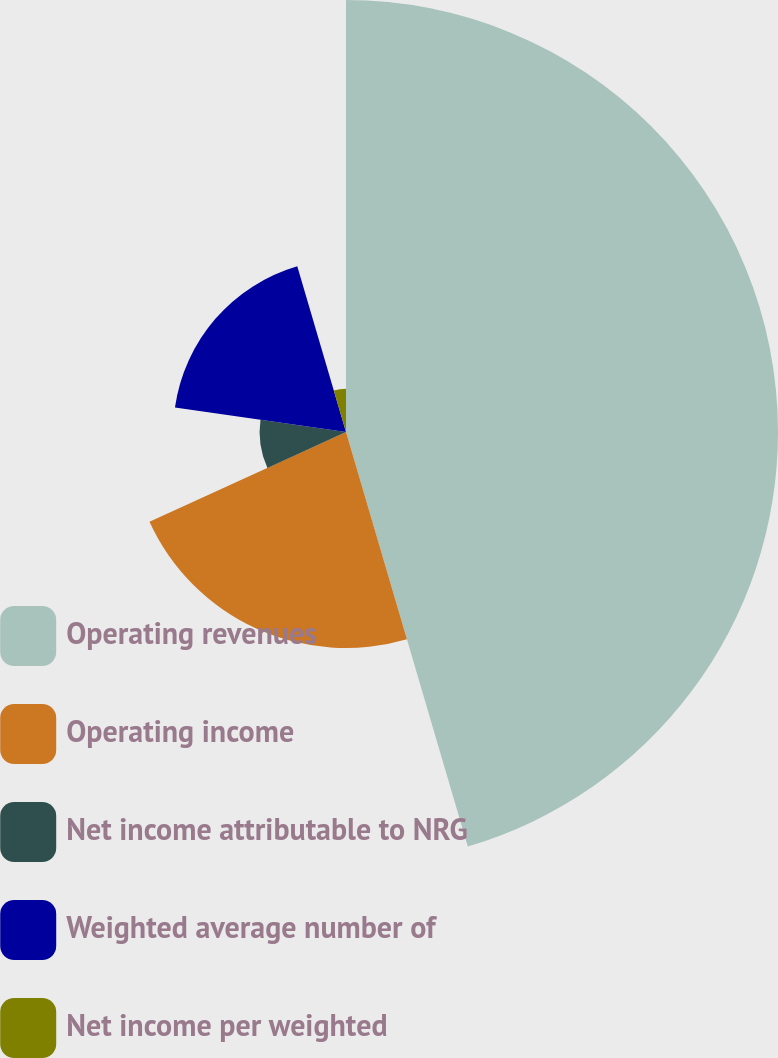Convert chart. <chart><loc_0><loc_0><loc_500><loc_500><pie_chart><fcel>Operating revenues<fcel>Operating income<fcel>Net income attributable to NRG<fcel>Weighted average number of<fcel>Net income per weighted<nl><fcel>45.45%<fcel>22.73%<fcel>9.09%<fcel>18.18%<fcel>4.55%<nl></chart> 